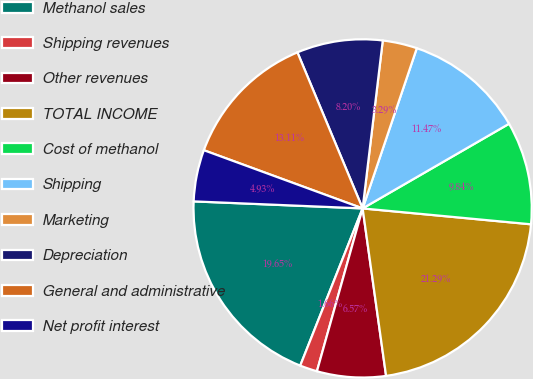Convert chart. <chart><loc_0><loc_0><loc_500><loc_500><pie_chart><fcel>Methanol sales<fcel>Shipping revenues<fcel>Other revenues<fcel>TOTAL INCOME<fcel>Cost of methanol<fcel>Shipping<fcel>Marketing<fcel>Depreciation<fcel>General and administrative<fcel>Net profit interest<nl><fcel>19.65%<fcel>1.66%<fcel>6.57%<fcel>21.29%<fcel>9.84%<fcel>11.47%<fcel>3.29%<fcel>8.2%<fcel>13.11%<fcel>4.93%<nl></chart> 